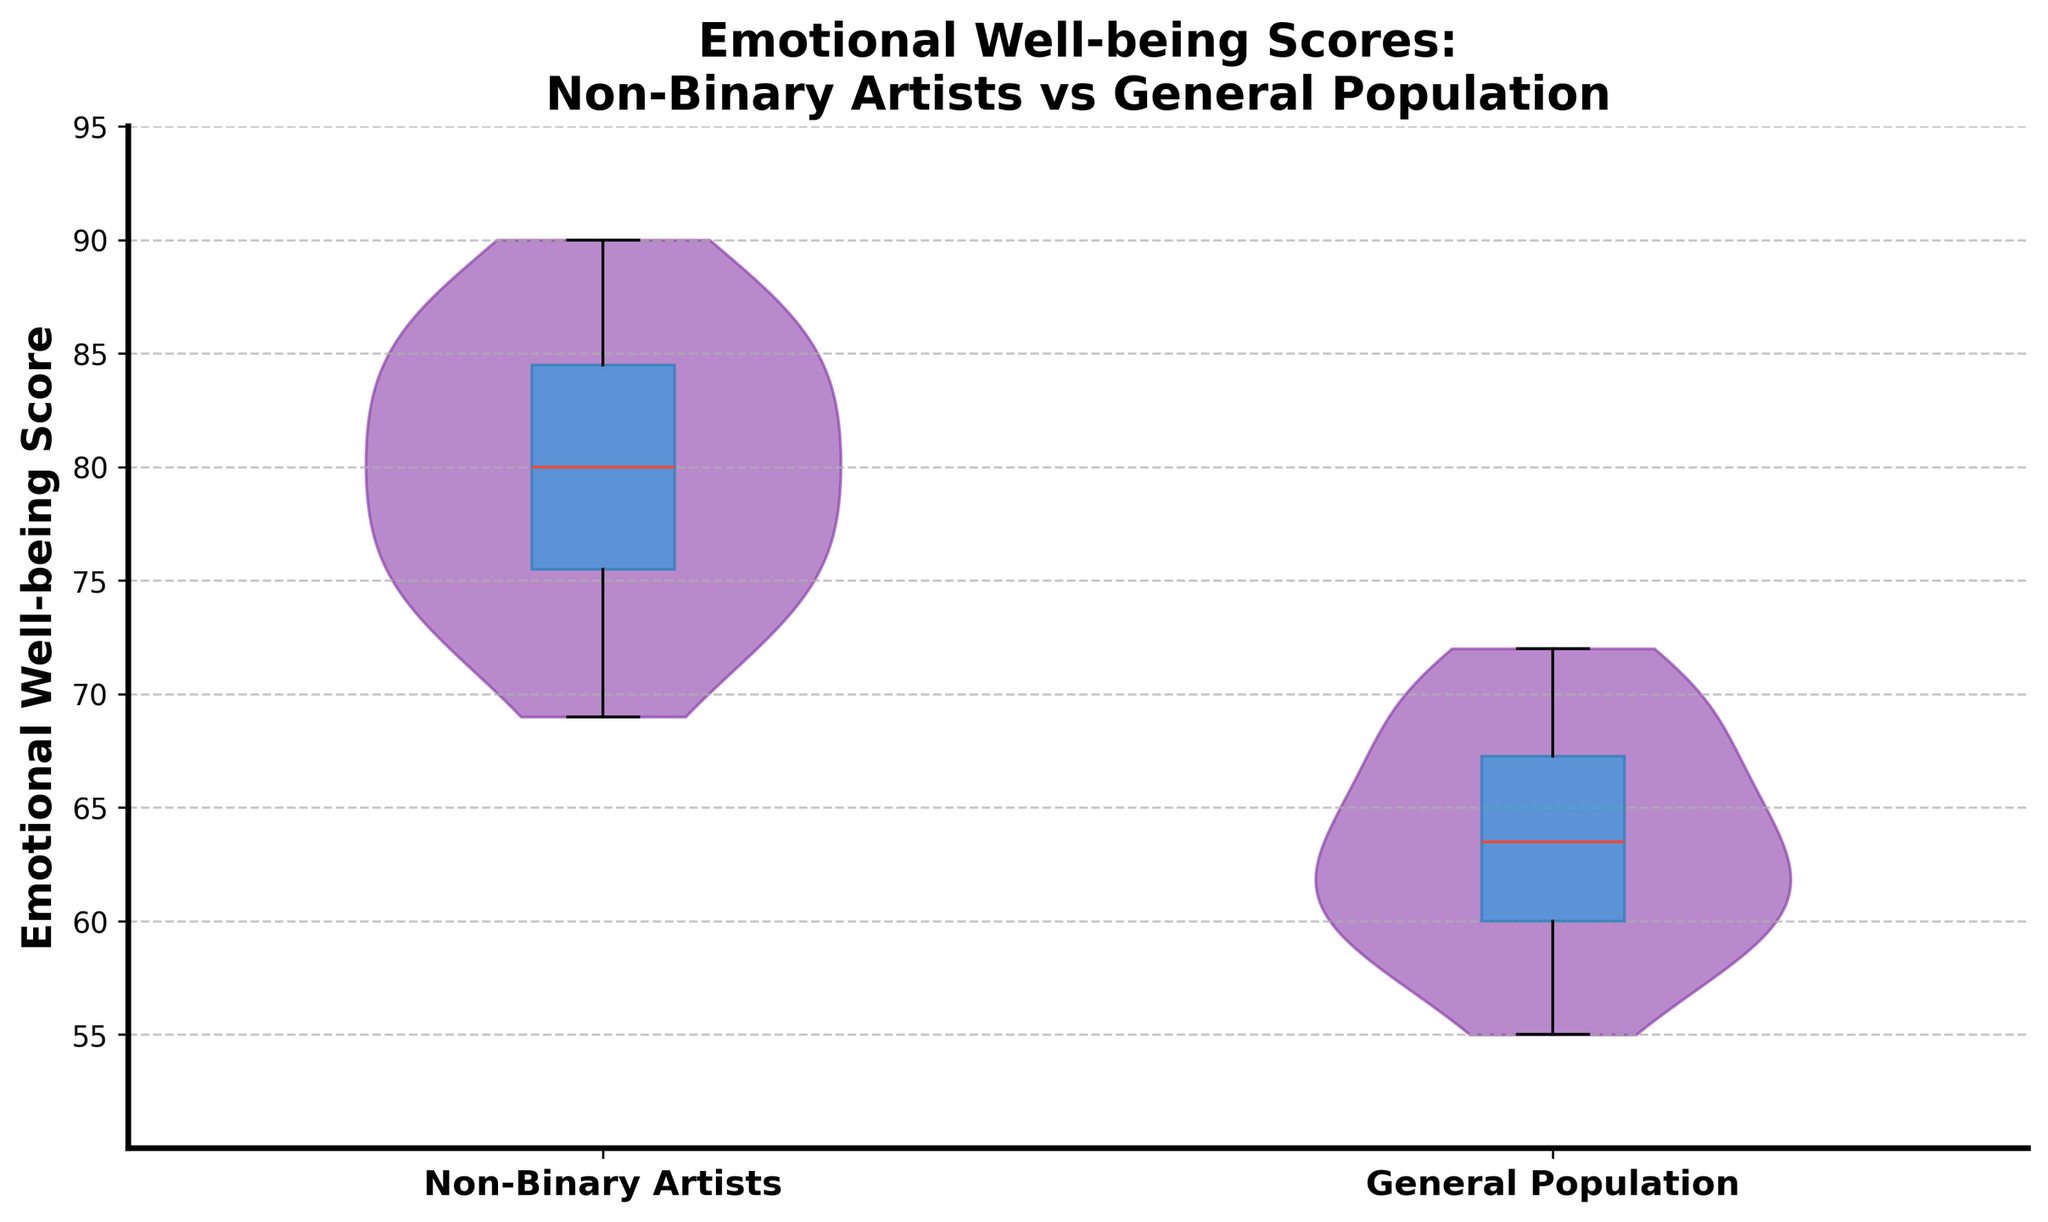what is the title of the figure? The title of a figure is usually at the top and provides a brief description of what the chart represents.
Answer: Emotional Well-being Scores: Non-Binary Artists vs General Population what do the x-axis labels indicate? On the x-axis, we have labels that categorize the data into two distinct groups. These labels tell us which categories are being compared within the figure.
Answer: Non-Binary Artists, General Population what does the y-axis represent? The y-axis of the figure represents a quantitative measure that allows us to compare levels of a variable. In this instance, it shows the range of scores for emotional well-being.
Answer: Emotional Well-being Score what's the range of scores for emotional well-being in the figure? The range of scores is shown along the y-axis of the figure. The lowest value starts around 50, and the highest value goes up to 95.
Answer: 50 to 95 which group has a higher median emotional well-being score? The median score for each group is indicated by the line in the box plot within the violin chart. Compare the positions of these lines to determine which is higher.
Answer: Non-Binary Artists which group has a larger interquartile range (IQR) for emotional well-being scores? The IQR is represented by the height of the box in the box plot. Compare the heights of the boxes for both groups to see which is larger.
Answer: General Population how does the overall spread of scores compare between the two groups? The violin plot visualizes the distribution and spread of the scores for each group. Look at the width and shape of the violin plots to assess the spread.
Answer: Non-Binary Artists have a wider spread what does the color of the violin plots indicate? The color of the violin plots is usually used to visually distinguish between different groups in the figure. In this instance, both violins are shaded similarly, indicating they belong to comparable groups.
Answer: Aesthetic element, no specific indication which group shows more varied emotional well-being scores? The violin plot's width shows variance. A wider spread indicates more varied scores. Compare the widths for each group to determine variance.
Answer: Non-Binary Artists what is the main takeaway from this violin plot with box plot overlay? Combining both visualizations - violin plot for distribution and box plot for summary statistics - allows us to see that Non-Binary Artists generally have higher and more varied emotional well-being scores compared to the General Population.
Answer: Non-Binary Artists have higher and more varied scores 